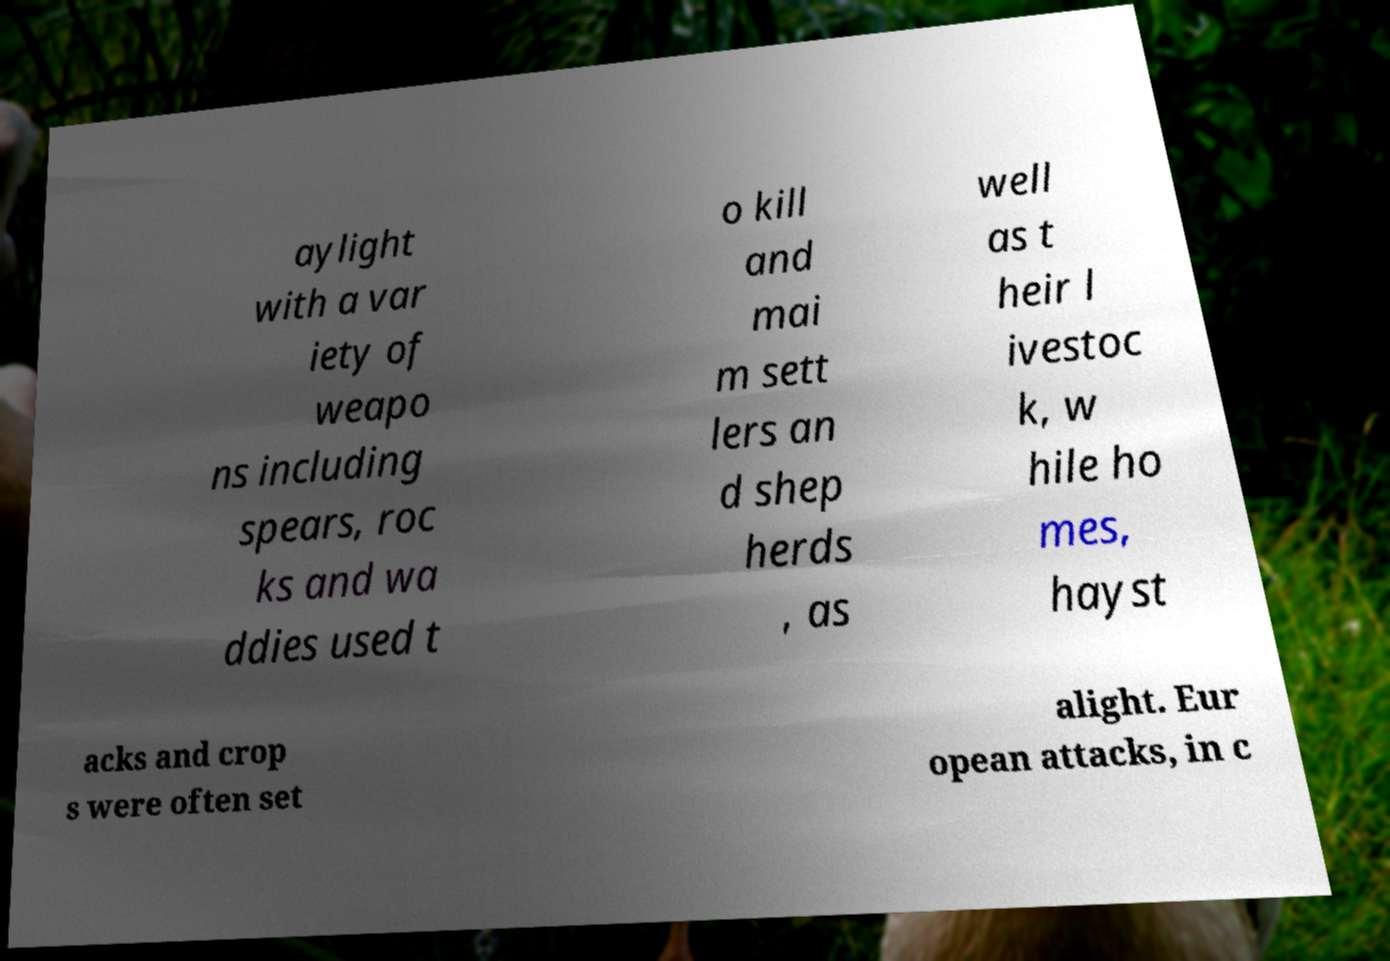Please read and relay the text visible in this image. What does it say? aylight with a var iety of weapo ns including spears, roc ks and wa ddies used t o kill and mai m sett lers an d shep herds , as well as t heir l ivestoc k, w hile ho mes, hayst acks and crop s were often set alight. Eur opean attacks, in c 